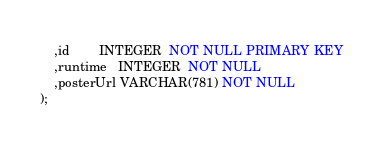<code> <loc_0><loc_0><loc_500><loc_500><_SQL_>    ,id        INTEGER  NOT NULL PRIMARY KEY
    ,runtime   INTEGER  NOT NULL
    ,posterUrl VARCHAR(781) NOT NULL
);</code> 